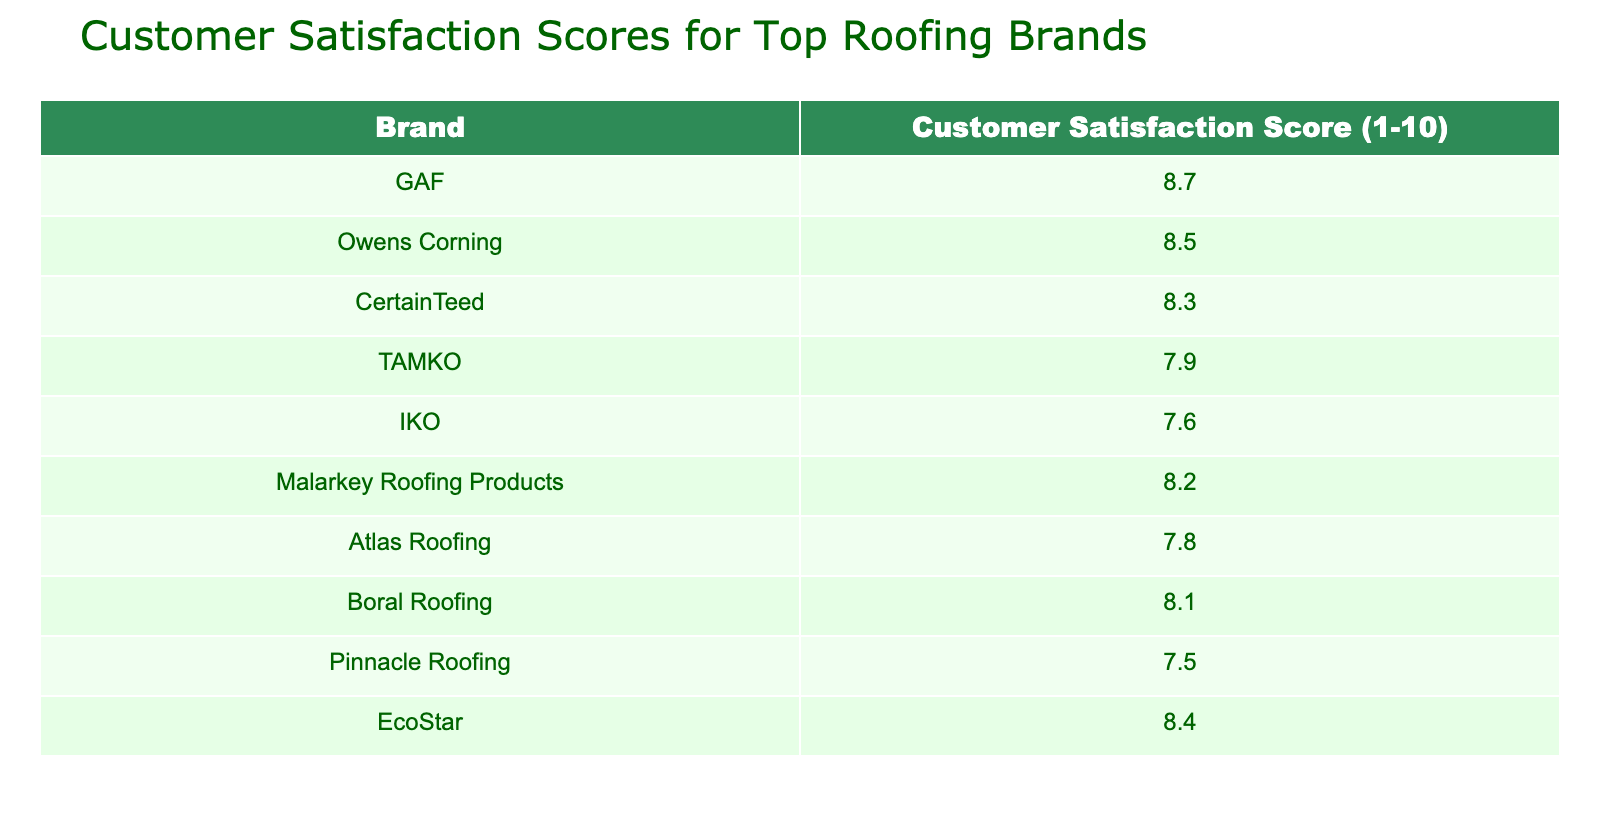What is the customer satisfaction score for GAF? The table indicates the score for GAF is listed directly under the "Customer Satisfaction Score" column next to the brand name GAF.
Answer: 8.7 Which brand has the highest customer satisfaction score? By examining the customer satisfaction scores from each brand, GAF has the highest score of 8.7, which is the largest value in the table.
Answer: GAF What is the average customer satisfaction score of the brands listed? To find the average, sum all the individual scores: (8.7 + 8.5 + 8.3 + 7.9 + 7.6 + 8.2 + 7.8 + 8.1 + 7.5 + 8.4) = 86.5. There are 10 brands, so divide by 10: 86.5 / 10 = 8.65.
Answer: 8.65 Is the customer satisfaction score for Malarkey Roofing Products higher than that of IKO? According to the table, Malarkey Roofing Products has a score of 8.2 while IKO has a score of 7.6. Since 8.2 is greater than 7.6, we conclude that Malarkey Roofing Products indeed has a higher score.
Answer: Yes What is the difference in customer satisfaction scores between the highest and lowest scoring brands? The highest score is GAF at 8.7 and the lowest score is Pinnacle Roofing at 7.5. To find the difference, subtract the lowest score from the highest: 8.7 - 7.5 = 1.2.
Answer: 1.2 How many brands have a customer satisfaction score below 8? By reviewing the scores below 8, we find TAMKO (7.9), IKO (7.6), Atlas Roofing (7.8), and Pinnacle Roofing (7.5). There are 4 brands that fall below the score of 8.
Answer: 4 Are there more brands with a score above 8 than those with a score below 8? Brands with scores above 8 are GAF (8.7), Owens Corning (8.5), CertainTeed (8.3), Malarkey Roofing Products (8.2), Boral Roofing (8.1), EcoStar (8.4) - totaling 6 brands. Brands below 8 are TAMKO (7.9), IKO (7.6), Atlas Roofing (7.8), and Pinnacle Roofing (7.5) - totaling 4 brands. Since 6 is greater than 4, there are indeed more brands above 8.
Answer: Yes What score does EcoStar have compared to the average score? EcoStar has a score of 8.4. The average score calculated previously is 8.65. Since 8.4 is less than 8.65, EcoStar's score is below the average.
Answer: Below average 